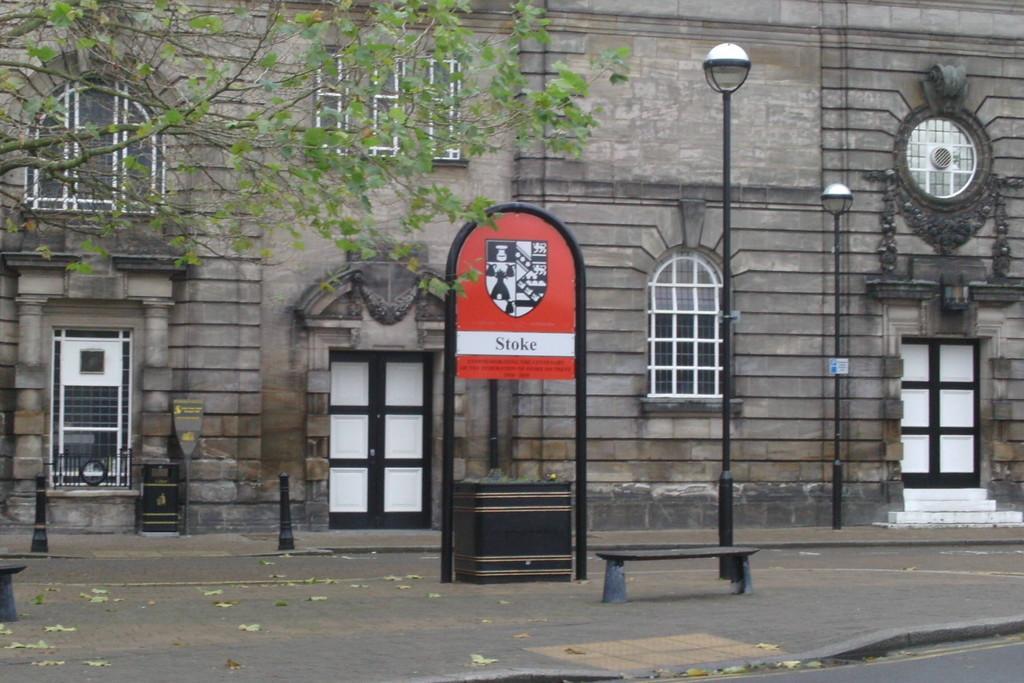Can you describe this image briefly? In this image, we can see a building and there are windows and doors and there are light poles and boards. At the bottom, there are traffic cones and a bench on the road. On the left, there is a tree. 